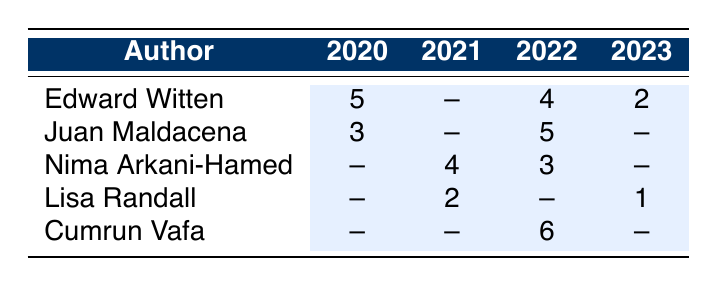What is the total number of publications by Edward Witten in 2022? Edward Witten has 4 publications listed for the year 2022 as shown in the table under his row.
Answer: 4 Which author had the highest number of publications in 2020? In 2020, Edward Witten had 5 publications, which is higher than Juan Maldacena's 3. Therefore, Witten had the most in that year.
Answer: Edward Witten How many publications did Nima Arkani-Hamed have in 2021? According to the table, Nima Arkani-Hamed had 4 publications in the year 2021, which can be found in his row under that column.
Answer: 4 How many total publications did Cumrun Vafa have between 2020 and 2022? Cumrun Vafa had no publications in 2020 and 2021, but had 6 in 2022. Therefore, his total is 0 + 0 + 6 = 6.
Answer: 6 Did Lisa Randall publish in 2022? In the table, it shows that Lisa Randall has no publications listed for the year 2022. Thus, the answer is no.
Answer: No What is the average number of publications for Juan Maldacena over the years listed? Juan Maldacena had 3 publications in 2020, 5 in 2022, and none in 2021 and 2023. Adding these gives 3 + 0 + 5 + 0 = 8, and dividing by 4 (the number of years) gives an average of 2.
Answer: 2 Which author had the least number of publications in 2023? In 2023, Lisa Randall had 1 publication while Edward Witten had 2. Therefore, Randall had the least in that year.
Answer: Lisa Randall What is the difference in the number of publications between Nima Arkani-Hamed in 2021 and Lisa Randall in 2023? Nima Arkani-Hamed had 4 publications in 2021 and Lisa Randall had 1 in 2023. The difference is 4 - 1 = 3.
Answer: 3 How many years did Edward Witten have publications listed in the table? Edward Witten has publications shown for the years 2020, 2022, and 2023. Counting those yields a total of 3 years.
Answer: 3 